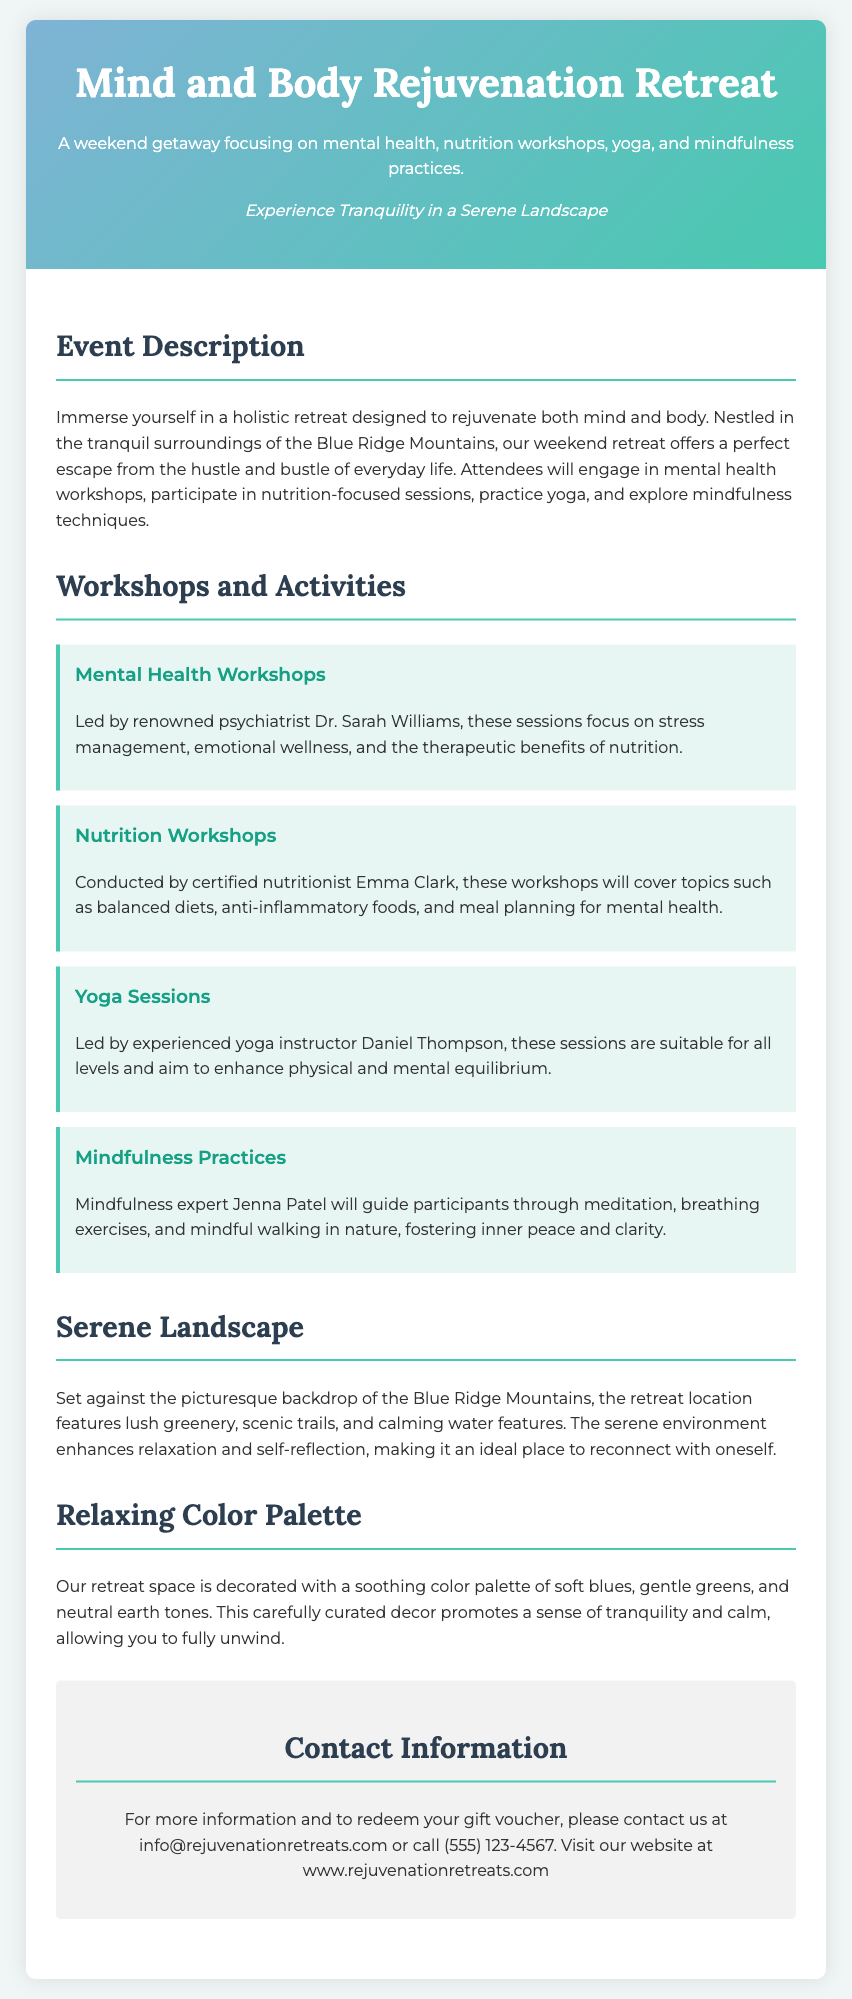What is the title of the retreat? The title of the retreat is clearly stated in the header section of the document.
Answer: Mind and Body Rejuvenation Retreat Who leads the Mental Health Workshops? The document specifies that these workshops are led by a renowned psychiatrist.
Answer: Dr. Sarah Williams What is one topic covered in the Nutrition Workshops? The document mentions several topics, one of which is found in the description of the workshops.
Answer: Balanced diets How many types of workshops are mentioned? The number of workshops can be found by counting the listed types of workshops in the document.
Answer: Four Where is the retreat located? This information can be found in the event description section of the document.
Answer: Blue Ridge Mountains What color palette is used in the retreat space? The document mentions specific colors used in the decor to promote tranquility.
Answer: Soft blues, gentle greens, and neutral earth tones What is the purpose of the retreats? The overall purpose of the retreat is mentioned in the introductory paragraph.
Answer: Rejuvenate both mind and body Who can participants contact for more information? The contact information section specifies who to reach out to for more details.
Answer: info@rejuvenationretreats.com What type of practices are included in the retreat activities? The activities of the retreat include various practices highlighted in the workshops section.
Answer: Mindfulness practices 